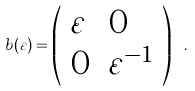Convert formula to latex. <formula><loc_0><loc_0><loc_500><loc_500>b ( \varepsilon ) = \left ( \begin{array} { l l } \varepsilon & 0 \\ 0 & \varepsilon ^ { - 1 } \end{array} \right ) \ .</formula> 